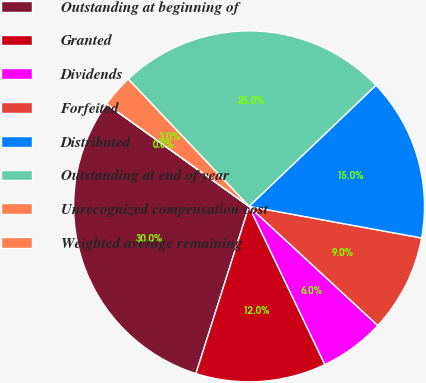Convert chart. <chart><loc_0><loc_0><loc_500><loc_500><pie_chart><fcel>Outstanding at beginning of<fcel>Granted<fcel>Dividends<fcel>Forfeited<fcel>Distributed<fcel>Outstanding at end of year<fcel>Unrecognized compensation cost<fcel>Weighted average remaining<nl><fcel>30.02%<fcel>12.01%<fcel>6.0%<fcel>9.0%<fcel>15.01%<fcel>24.96%<fcel>3.0%<fcel>0.0%<nl></chart> 